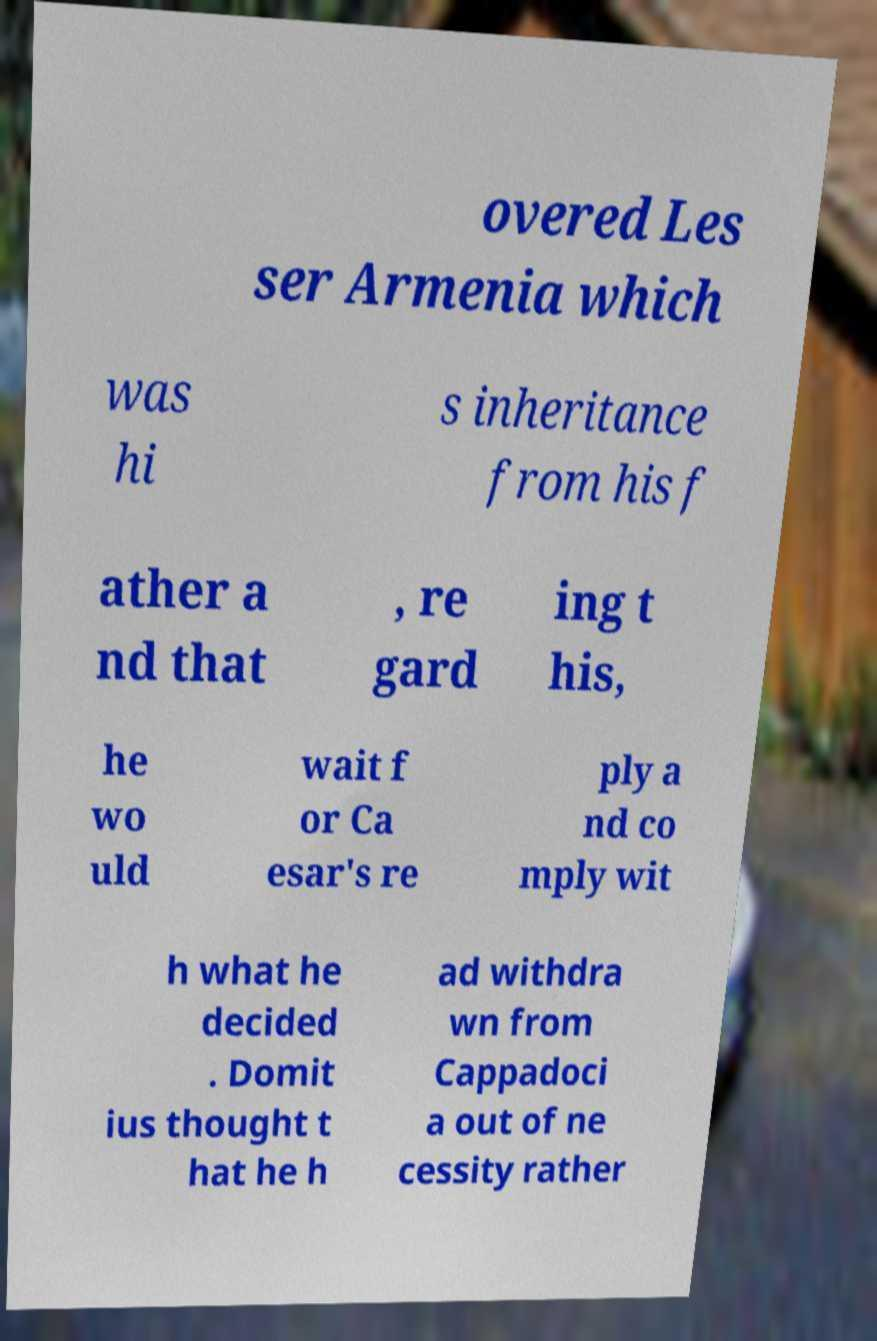Could you assist in decoding the text presented in this image and type it out clearly? overed Les ser Armenia which was hi s inheritance from his f ather a nd that , re gard ing t his, he wo uld wait f or Ca esar's re ply a nd co mply wit h what he decided . Domit ius thought t hat he h ad withdra wn from Cappadoci a out of ne cessity rather 